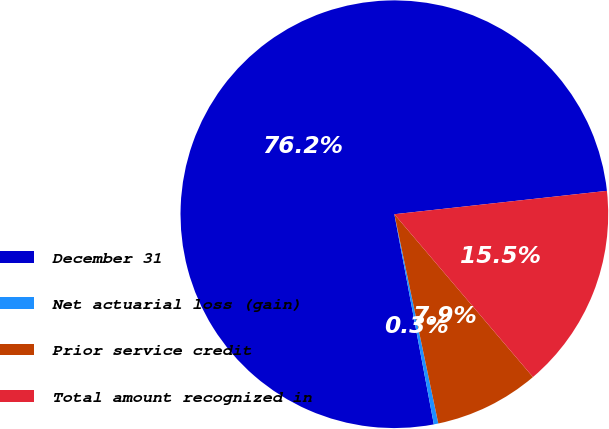Convert chart. <chart><loc_0><loc_0><loc_500><loc_500><pie_chart><fcel>December 31<fcel>Net actuarial loss (gain)<fcel>Prior service credit<fcel>Total amount recognized in<nl><fcel>76.22%<fcel>0.34%<fcel>7.93%<fcel>15.52%<nl></chart> 